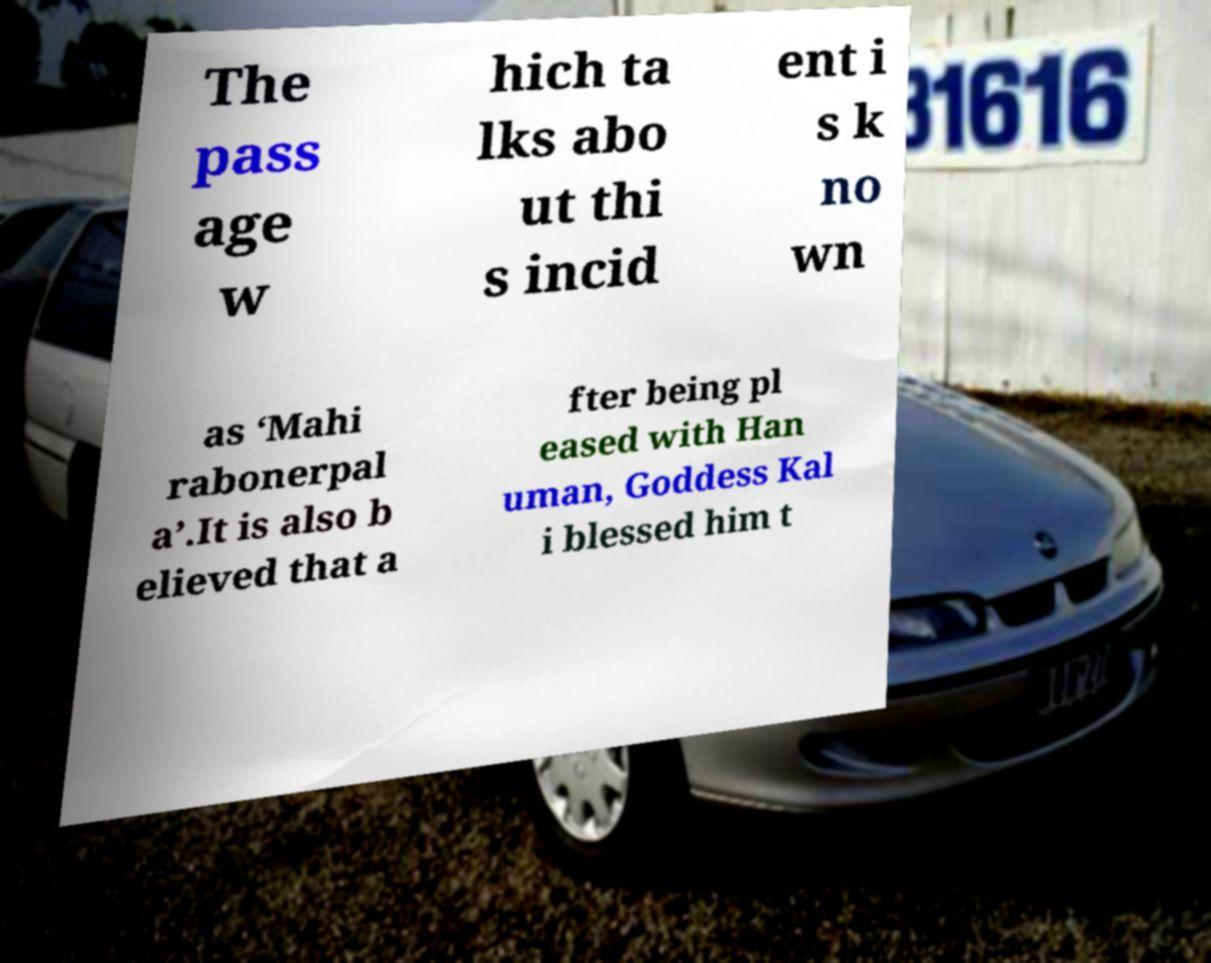For documentation purposes, I need the text within this image transcribed. Could you provide that? The pass age w hich ta lks abo ut thi s incid ent i s k no wn as ‘Mahi rabonerpal a’.It is also b elieved that a fter being pl eased with Han uman, Goddess Kal i blessed him t 